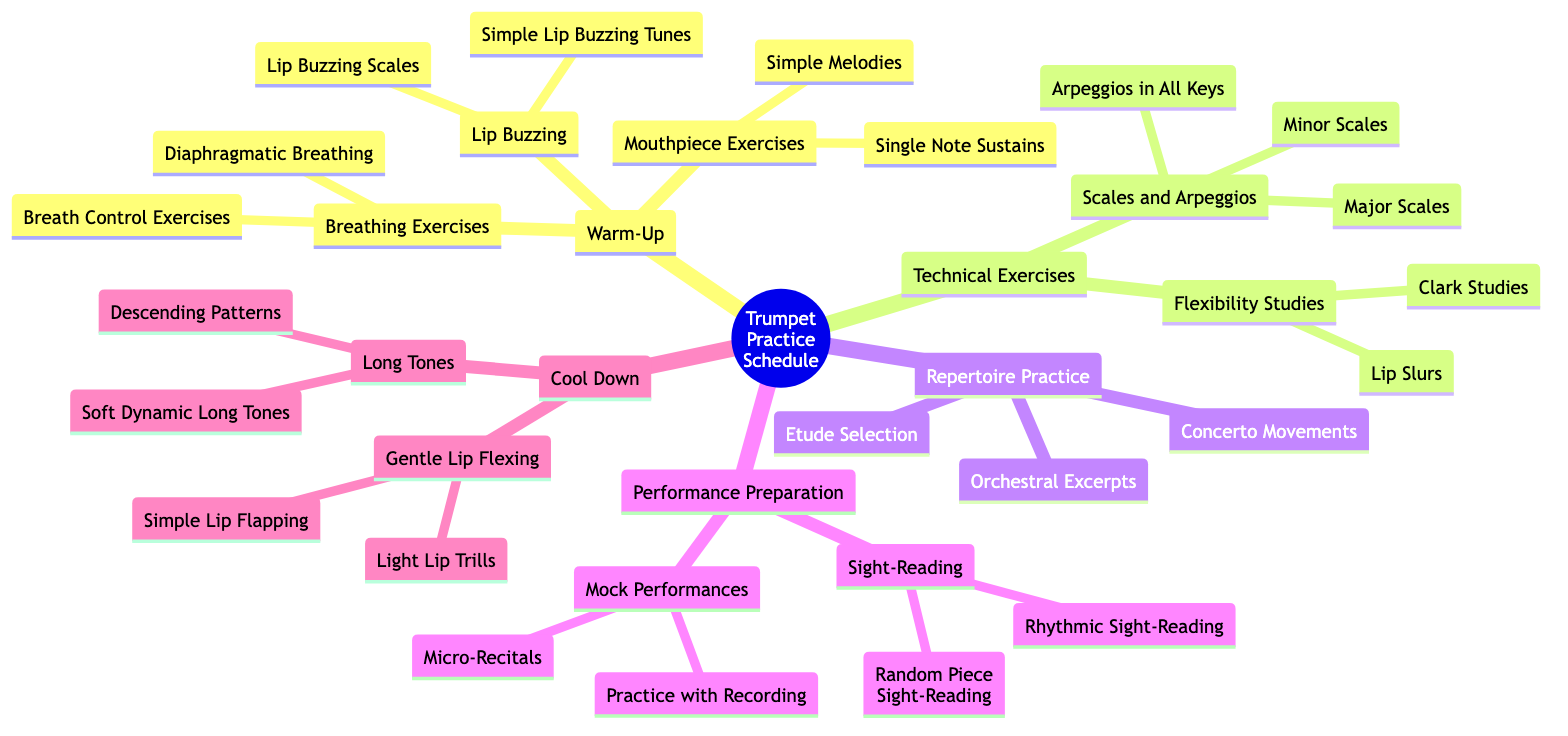What is the main topic of the mind map? The primary focus of the mind map is indicated clearly at the root node labeled "Trumpet Practice Schedule."
Answer: Trumpet Practice Schedule How many subtopics are there under "Warm-Up"? By looking at the nodes under "Warm-Up," there are three subtopics: Breathing Exercises, Lip Buzzing, and Mouthpiece Exercises.
Answer: 3 What exercises are included in the "Lip Buzzing" subtopic? The "Lip Buzzing" subtopic lists two exercises: "Lip Buzzing Scales" and "Simple Lip Buzzing Tunes."
Answer: Lip Buzzing Scales, Simple Lip Buzzing Tunes Which techniques are found under the "Sight-Reading" subtopic? In the "Sight-Reading" subtopic, there are two techniques mentioned: "Random Piece Sight-Reading" and "Rhythmic Sight-Reading."
Answer: Random Piece Sight-Reading, Rhythmic Sight-Reading What is the last subtopic listed under "Cool Down"? The last subtopic listed under "Cool Down" is "Gentle Lip Flexing." To confirm, we can see that "Long Tones" comes before it.
Answer: Gentle Lip Flexing How many exercises are under "Flexibility Studies"? The "Flexibility Studies" subtopic contains two exercises mentioned: "Lip Slurs" and "Clark Studies."
Answer: 2 What is the relationship between "Technical Exercises" and "Repertoire Practice"? "Technical Exercises" and "Repertoire Practice" are both main subtopics under the root topic "Trumpet Practice Schedule," showing they are sibling nodes at the same level.
Answer: Sibling subtopics Which subtopic includes "Micro-Recitals"? "Micro-Recitals" is an exercise found under the "Mock Performances" subtopic, which is part of the "Performance Preparation." To ascertain this, we can trace the node connections starting from "Performance Preparation."
Answer: Mock Performances What type of exercises can be found in the "Long Tones" subtopic? Under the "Long Tones," there are two exercises specified: "Soft Dynamic Long Tones" and "Descending Patterns."
Answer: Soft Dynamic Long Tones, Descending Patterns 